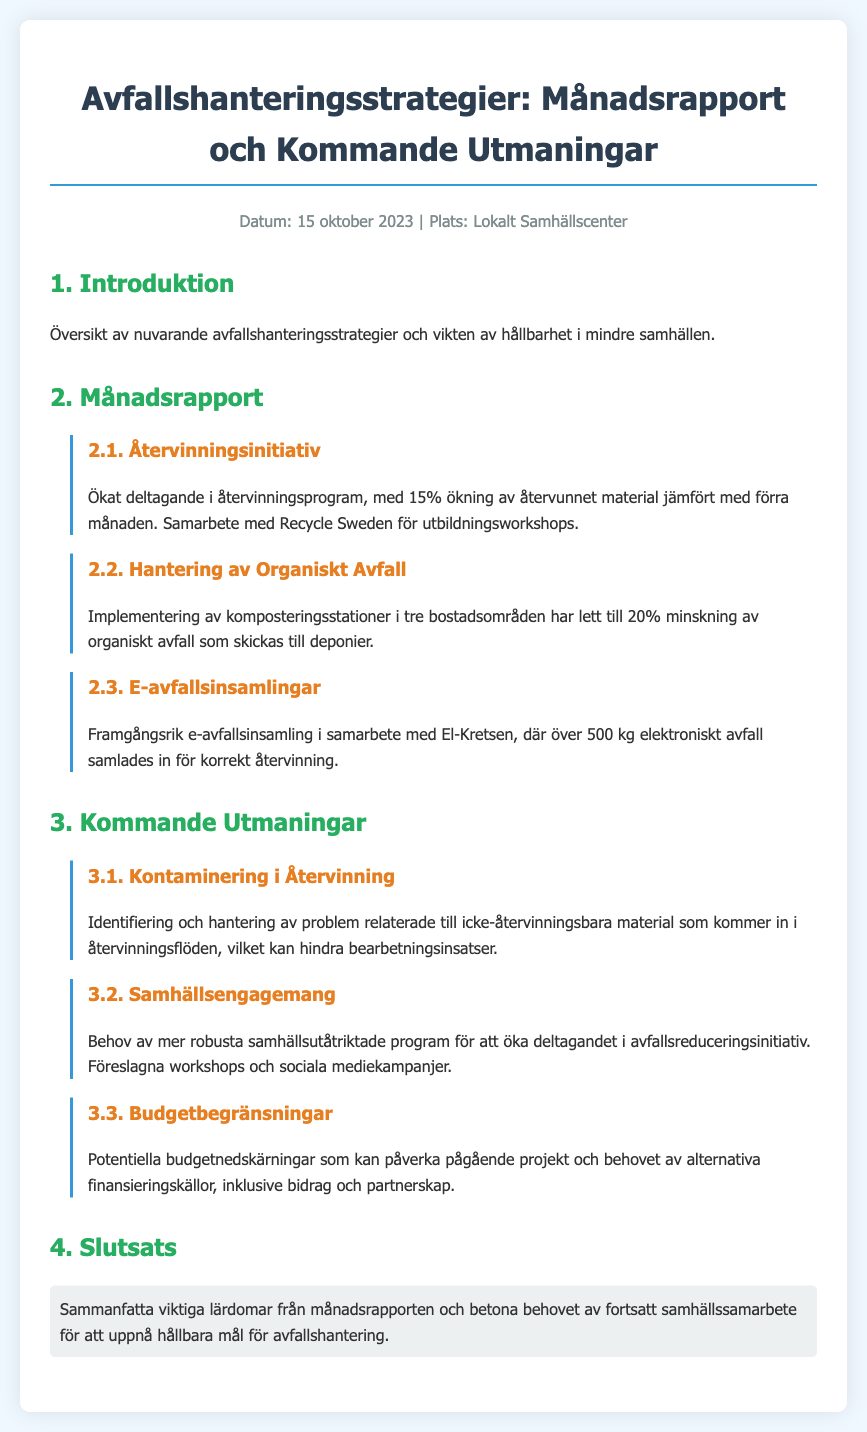Vad är procentuell ökning av återvunnet material? Rapporten nämner en 15% ökning av återvunnet material jämfört med förra månaden.
Answer: 15% I vilka bostadsområden har komposteringsstationer implementerats? Rapporten anger att komposteringsstationer har införts i tre bostadsområden.
Answer: Tre Vilket samarbete nämns i samband med e-avfallsinsamlingar? Det nämns ett samarbete med El-Kretsen för insamling av elektroniskt avfall.
Answer: El-Kretsen Vad är en identifierad utmaning relaterad till återvinning? Rapporten nämner kontaminering av icke-återvinningsbara material som en huvudutmaning.
Answer: Kontaminering Vad önskar rapporten öka för att förbättra avfallsreducering? Det föreslås robusta samhällsutåtriktade program för att öka engagemanget.
Answer: Samhällsutåtriktade program Vilket datum gjordes rapporten? Datumet för rapporten är angivet som den 15 oktober 2023.
Answer: 15 oktober 2023 Vad har skett med det organiska avfallet i rapporten? Framgången är en 20% minskning av organiskt avfall som skickas till deponier.
Answer: 20% minskning Vilken organisation erbjuder utbildningsworkshops? Rapporten nämner samarbete med Recycle Sweden för utbildning.
Answer: Recycle Sweden Vilken utmaning kan påverka pågående projekt? Rapporten talar om potentiella budgetnedskärningar som en utmaning för projekt.
Answer: Budgetnedskärningar 